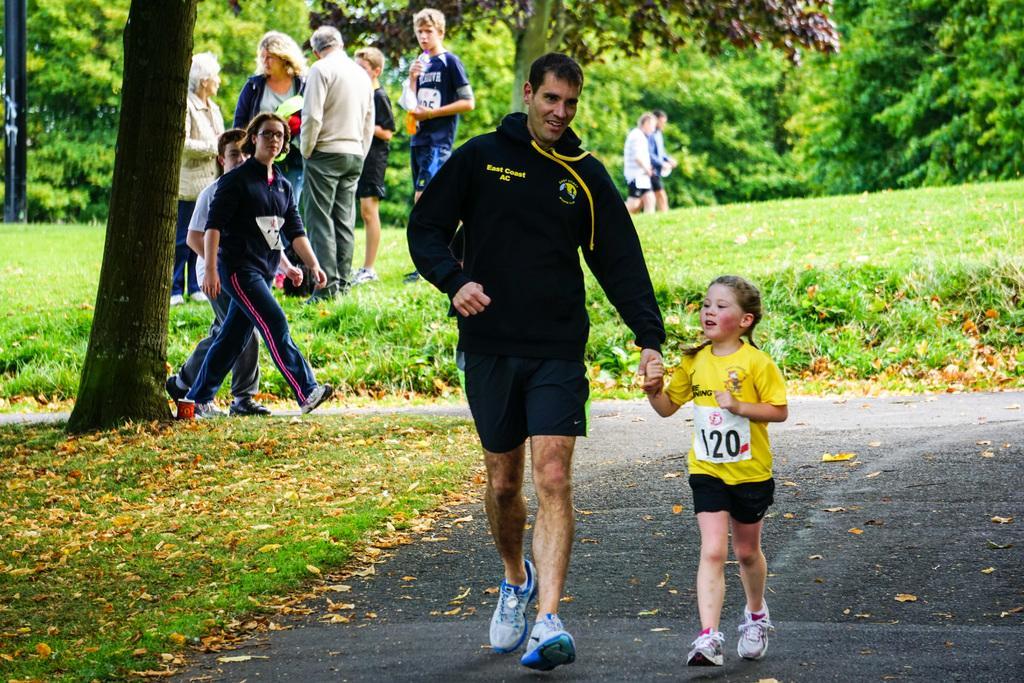Can you describe this image briefly? In this picture we can see four people walking on the road, dried leaves on the grass and in the background we can see some people and trees. 